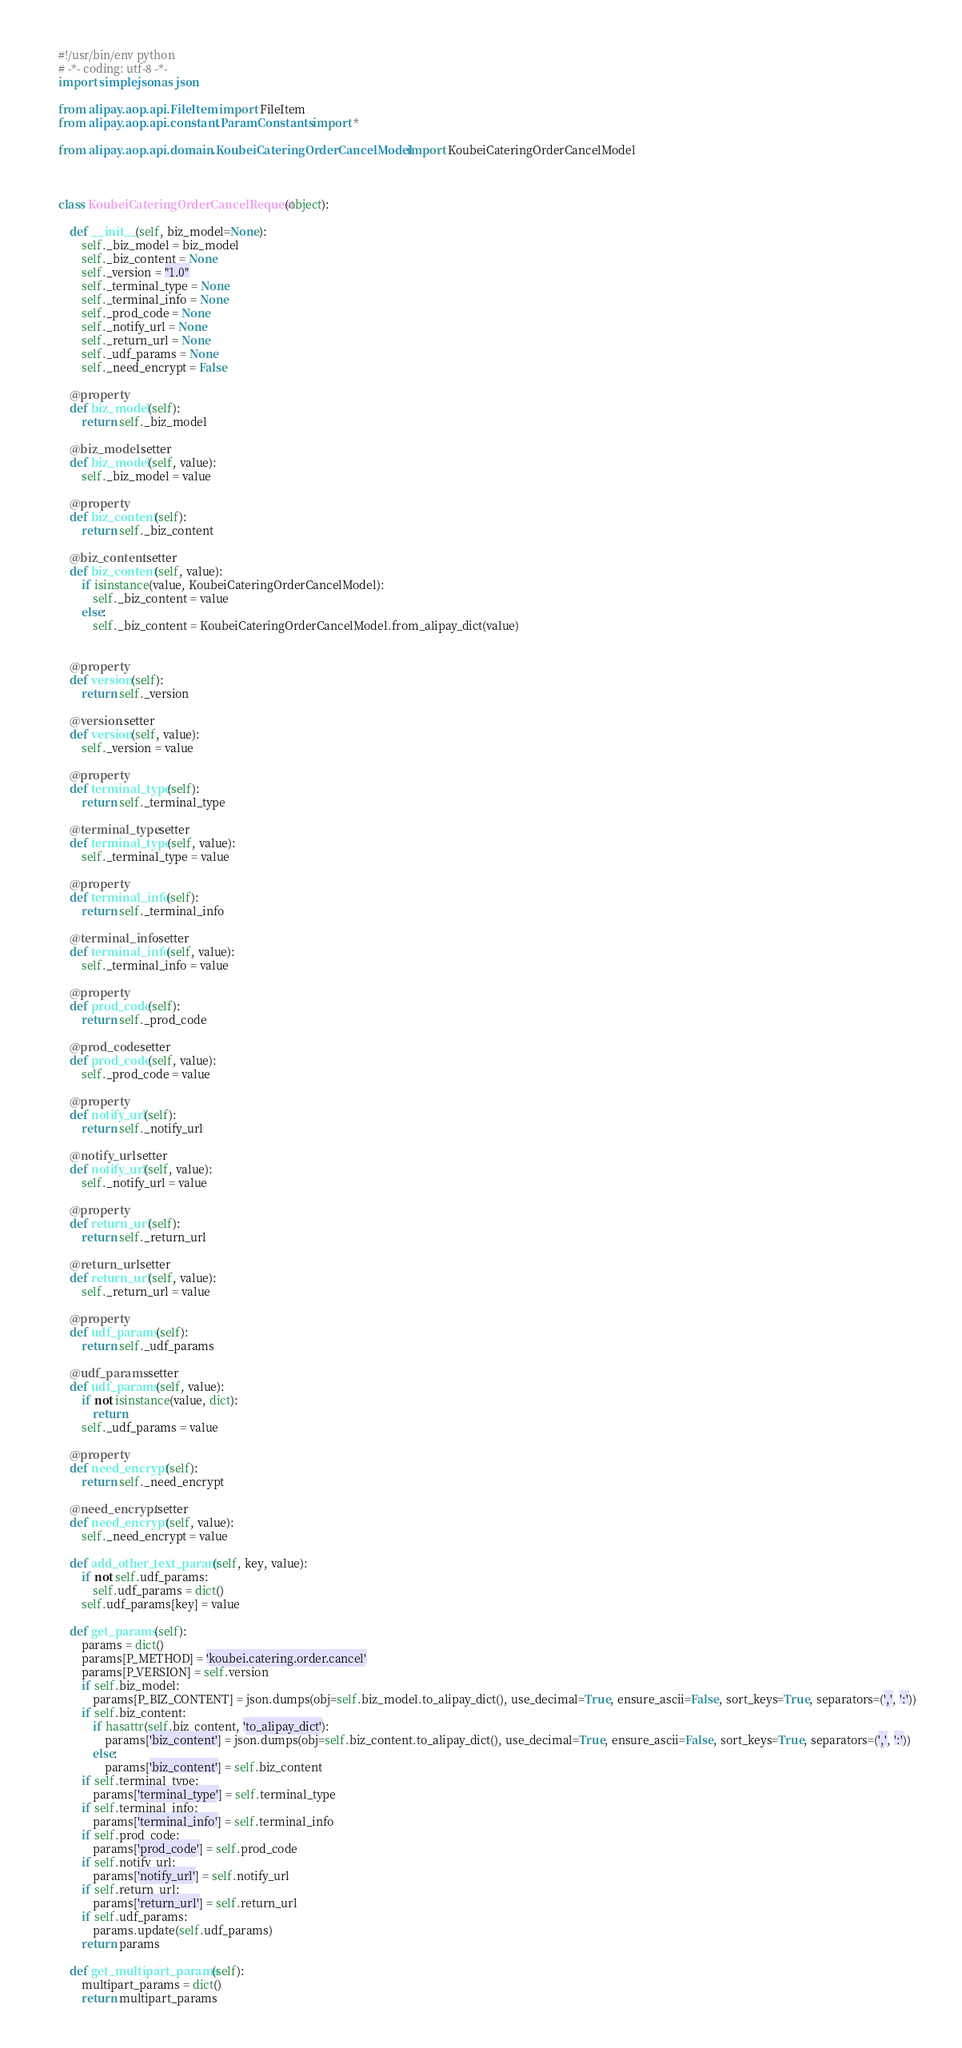Convert code to text. <code><loc_0><loc_0><loc_500><loc_500><_Python_>#!/usr/bin/env python
# -*- coding: utf-8 -*-
import simplejson as json

from alipay.aop.api.FileItem import FileItem
from alipay.aop.api.constant.ParamConstants import *

from alipay.aop.api.domain.KoubeiCateringOrderCancelModel import KoubeiCateringOrderCancelModel



class KoubeiCateringOrderCancelRequest(object):

    def __init__(self, biz_model=None):
        self._biz_model = biz_model
        self._biz_content = None
        self._version = "1.0"
        self._terminal_type = None
        self._terminal_info = None
        self._prod_code = None
        self._notify_url = None
        self._return_url = None
        self._udf_params = None
        self._need_encrypt = False

    @property
    def biz_model(self):
        return self._biz_model

    @biz_model.setter
    def biz_model(self, value):
        self._biz_model = value

    @property
    def biz_content(self):
        return self._biz_content

    @biz_content.setter
    def biz_content(self, value):
        if isinstance(value, KoubeiCateringOrderCancelModel):
            self._biz_content = value
        else:
            self._biz_content = KoubeiCateringOrderCancelModel.from_alipay_dict(value)


    @property
    def version(self):
        return self._version

    @version.setter
    def version(self, value):
        self._version = value

    @property
    def terminal_type(self):
        return self._terminal_type

    @terminal_type.setter
    def terminal_type(self, value):
        self._terminal_type = value

    @property
    def terminal_info(self):
        return self._terminal_info

    @terminal_info.setter
    def terminal_info(self, value):
        self._terminal_info = value

    @property
    def prod_code(self):
        return self._prod_code

    @prod_code.setter
    def prod_code(self, value):
        self._prod_code = value

    @property
    def notify_url(self):
        return self._notify_url

    @notify_url.setter
    def notify_url(self, value):
        self._notify_url = value

    @property
    def return_url(self):
        return self._return_url

    @return_url.setter
    def return_url(self, value):
        self._return_url = value

    @property
    def udf_params(self):
        return self._udf_params

    @udf_params.setter
    def udf_params(self, value):
        if not isinstance(value, dict):
            return
        self._udf_params = value

    @property
    def need_encrypt(self):
        return self._need_encrypt

    @need_encrypt.setter
    def need_encrypt(self, value):
        self._need_encrypt = value

    def add_other_text_param(self, key, value):
        if not self.udf_params:
            self.udf_params = dict()
        self.udf_params[key] = value

    def get_params(self):
        params = dict()
        params[P_METHOD] = 'koubei.catering.order.cancel'
        params[P_VERSION] = self.version
        if self.biz_model:
            params[P_BIZ_CONTENT] = json.dumps(obj=self.biz_model.to_alipay_dict(), use_decimal=True, ensure_ascii=False, sort_keys=True, separators=(',', ':'))
        if self.biz_content:
            if hasattr(self.biz_content, 'to_alipay_dict'):
                params['biz_content'] = json.dumps(obj=self.biz_content.to_alipay_dict(), use_decimal=True, ensure_ascii=False, sort_keys=True, separators=(',', ':'))
            else:
                params['biz_content'] = self.biz_content
        if self.terminal_type:
            params['terminal_type'] = self.terminal_type
        if self.terminal_info:
            params['terminal_info'] = self.terminal_info
        if self.prod_code:
            params['prod_code'] = self.prod_code
        if self.notify_url:
            params['notify_url'] = self.notify_url
        if self.return_url:
            params['return_url'] = self.return_url
        if self.udf_params:
            params.update(self.udf_params)
        return params

    def get_multipart_params(self):
        multipart_params = dict()
        return multipart_params
</code> 